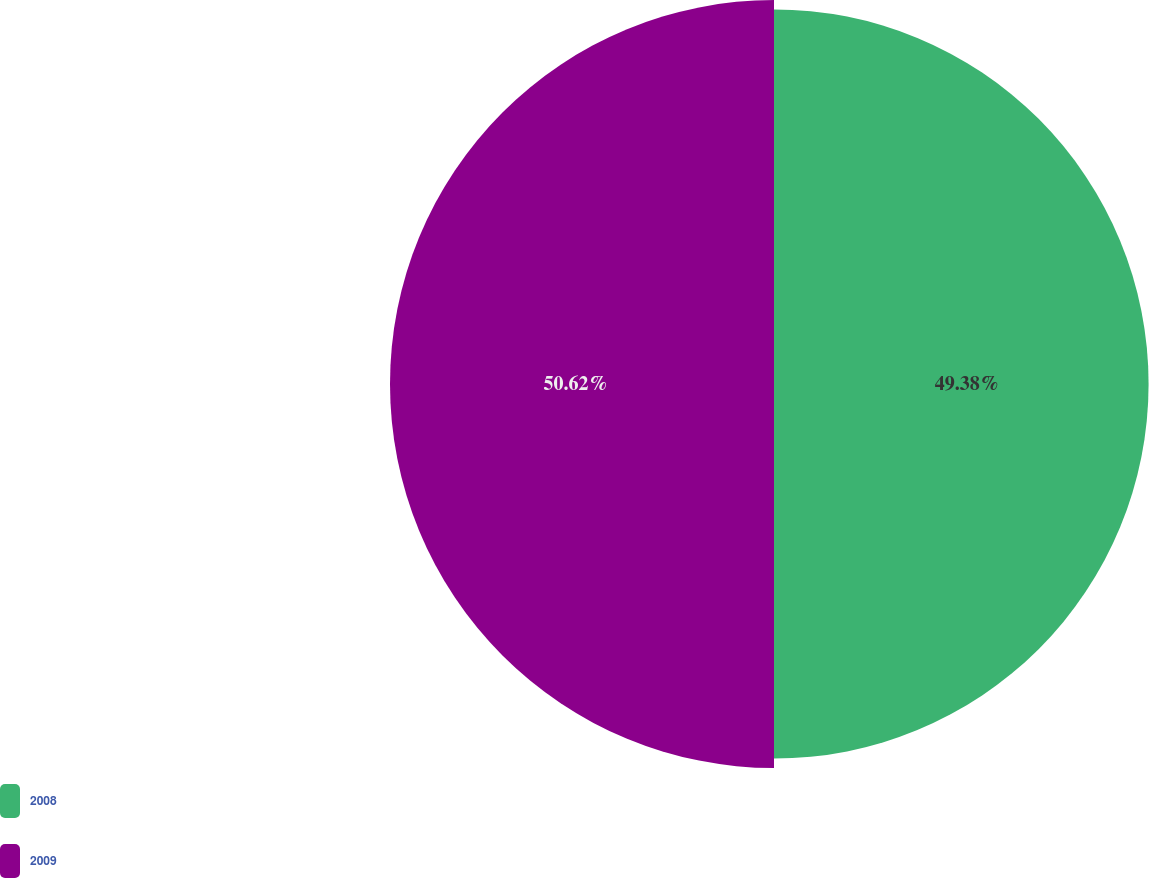<chart> <loc_0><loc_0><loc_500><loc_500><pie_chart><fcel>2008<fcel>2009<nl><fcel>49.38%<fcel>50.62%<nl></chart> 